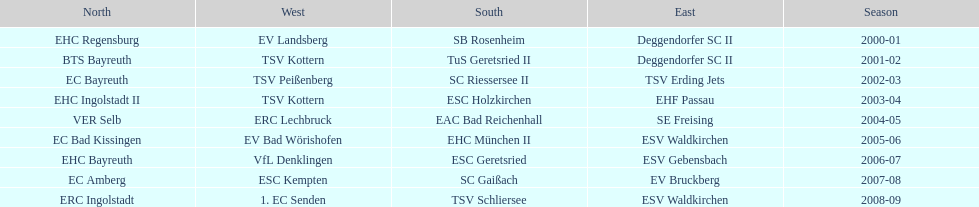The last team to win the west? 1. EC Senden. 